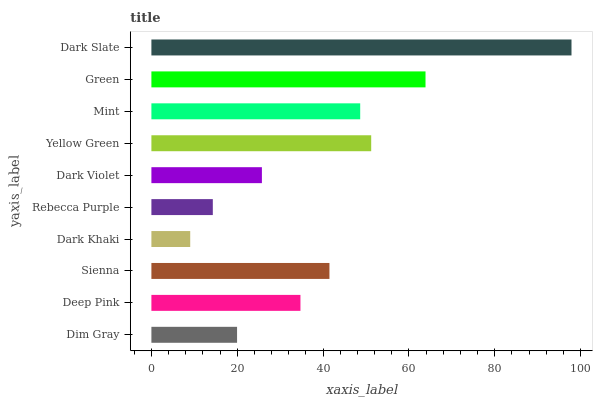Is Dark Khaki the minimum?
Answer yes or no. Yes. Is Dark Slate the maximum?
Answer yes or no. Yes. Is Deep Pink the minimum?
Answer yes or no. No. Is Deep Pink the maximum?
Answer yes or no. No. Is Deep Pink greater than Dim Gray?
Answer yes or no. Yes. Is Dim Gray less than Deep Pink?
Answer yes or no. Yes. Is Dim Gray greater than Deep Pink?
Answer yes or no. No. Is Deep Pink less than Dim Gray?
Answer yes or no. No. Is Sienna the high median?
Answer yes or no. Yes. Is Deep Pink the low median?
Answer yes or no. Yes. Is Dim Gray the high median?
Answer yes or no. No. Is Rebecca Purple the low median?
Answer yes or no. No. 